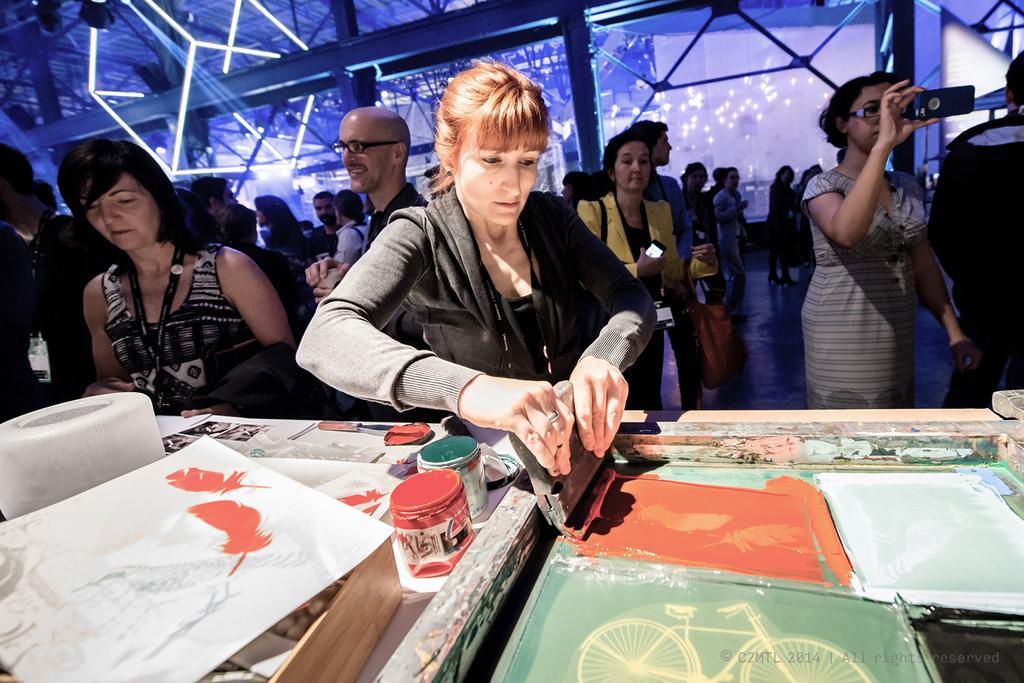How would you summarize this image in a sentence or two? In this picture, we see many people standing. On the right side, the girl in grey dress is holding a mobile phone in her hands and she is clicking photos. The woman in black jacket is holding the wood in her hands. In front of her, we see a table on which paint boxes and papers are placed. Behind them, we see a glass door and this picture might be clicked in the exhibition hall. 